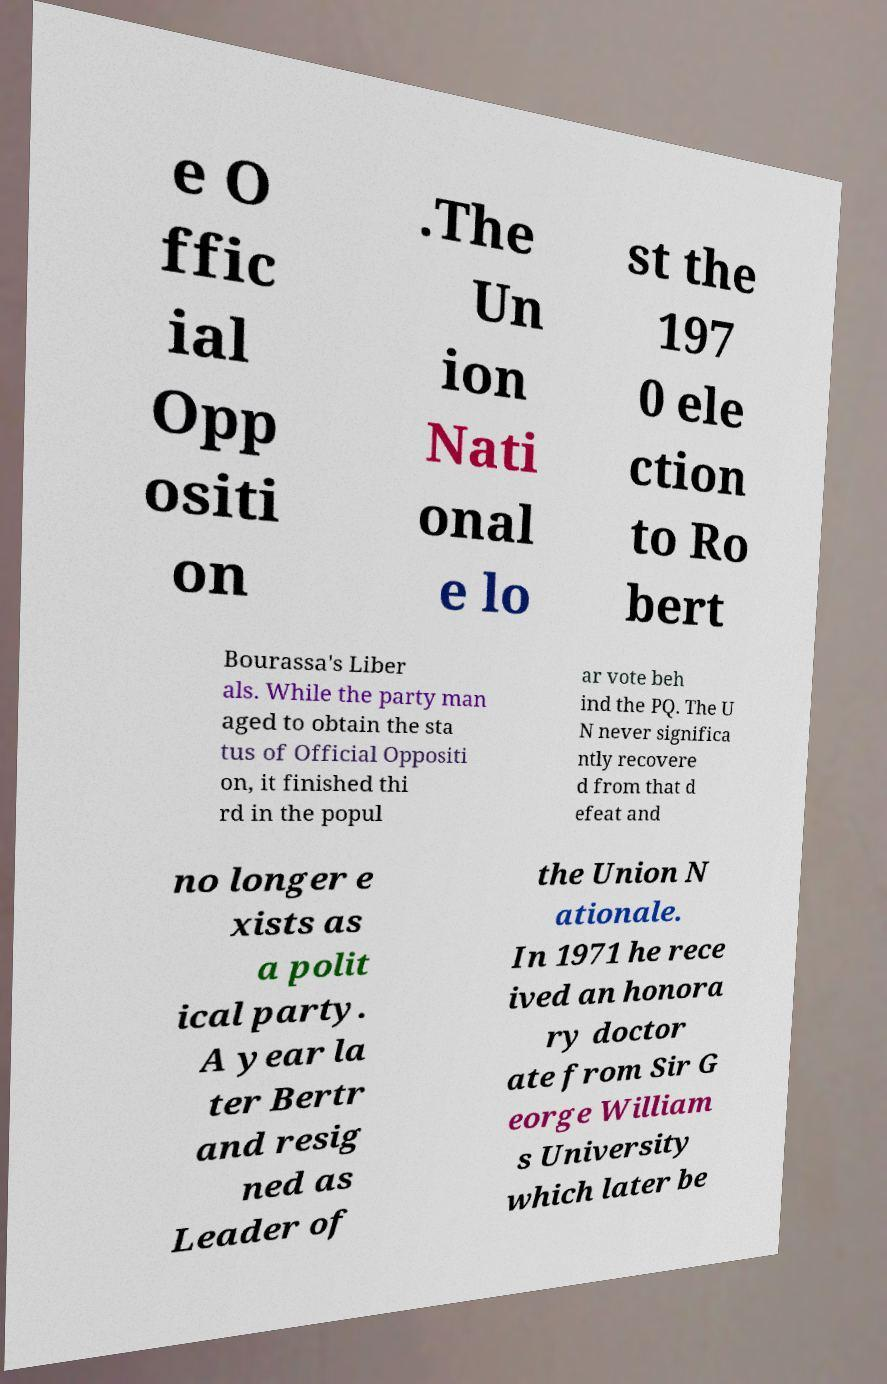Can you accurately transcribe the text from the provided image for me? e O ffic ial Opp ositi on .The Un ion Nati onal e lo st the 197 0 ele ction to Ro bert Bourassa's Liber als. While the party man aged to obtain the sta tus of Official Oppositi on, it finished thi rd in the popul ar vote beh ind the PQ. The U N never significa ntly recovere d from that d efeat and no longer e xists as a polit ical party. A year la ter Bertr and resig ned as Leader of the Union N ationale. In 1971 he rece ived an honora ry doctor ate from Sir G eorge William s University which later be 